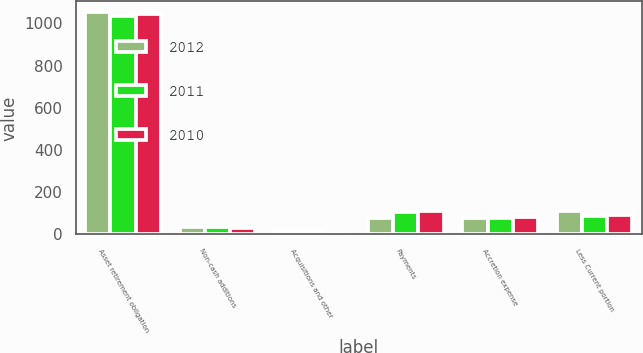Convert chart. <chart><loc_0><loc_0><loc_500><loc_500><stacked_bar_chart><ecel><fcel>Asset retirement obligation<fcel>Non-cash additions<fcel>Acquisitions and other<fcel>Payments<fcel>Accretion expense<fcel>Less Current portion<nl><fcel>2012<fcel>1052.4<fcel>33.8<fcel>14.6<fcel>77.6<fcel>78.4<fcel>110.4<nl><fcel>2011<fcel>1037<fcel>33.9<fcel>15.8<fcel>105.7<fcel>78<fcel>85.2<nl><fcel>2010<fcel>1046.5<fcel>31.4<fcel>3<fcel>111.3<fcel>80.5<fcel>93.9<nl></chart> 